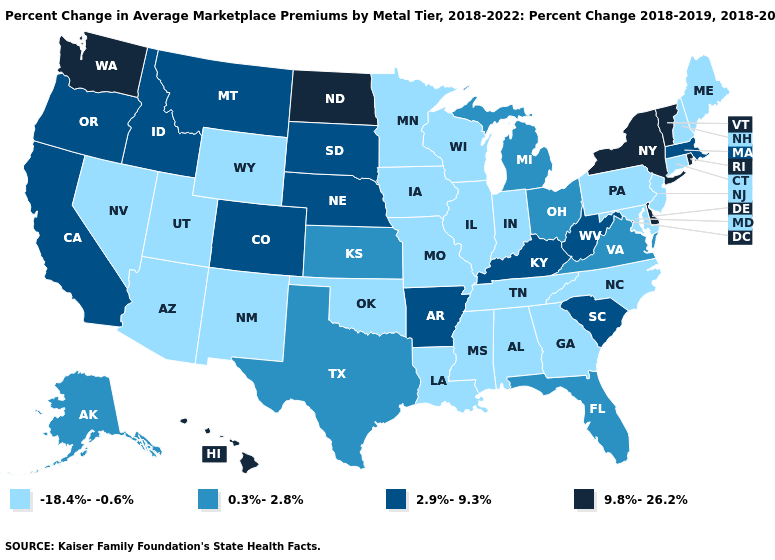Name the states that have a value in the range 2.9%-9.3%?
Write a very short answer. Arkansas, California, Colorado, Idaho, Kentucky, Massachusetts, Montana, Nebraska, Oregon, South Carolina, South Dakota, West Virginia. Does Kansas have a higher value than Louisiana?
Quick response, please. Yes. Which states hav the highest value in the MidWest?
Write a very short answer. North Dakota. Which states have the lowest value in the MidWest?
Write a very short answer. Illinois, Indiana, Iowa, Minnesota, Missouri, Wisconsin. What is the value of Illinois?
Concise answer only. -18.4%--0.6%. What is the value of New Jersey?
Give a very brief answer. -18.4%--0.6%. Does New Hampshire have the highest value in the Northeast?
Write a very short answer. No. Among the states that border Kansas , does Missouri have the highest value?
Answer briefly. No. How many symbols are there in the legend?
Answer briefly. 4. What is the lowest value in states that border New Mexico?
Short answer required. -18.4%--0.6%. What is the value of Tennessee?
Give a very brief answer. -18.4%--0.6%. Does Delaware have the highest value in the USA?
Give a very brief answer. Yes. Name the states that have a value in the range 9.8%-26.2%?
Concise answer only. Delaware, Hawaii, New York, North Dakota, Rhode Island, Vermont, Washington. What is the value of South Dakota?
Short answer required. 2.9%-9.3%. Among the states that border North Dakota , does Montana have the lowest value?
Write a very short answer. No. 